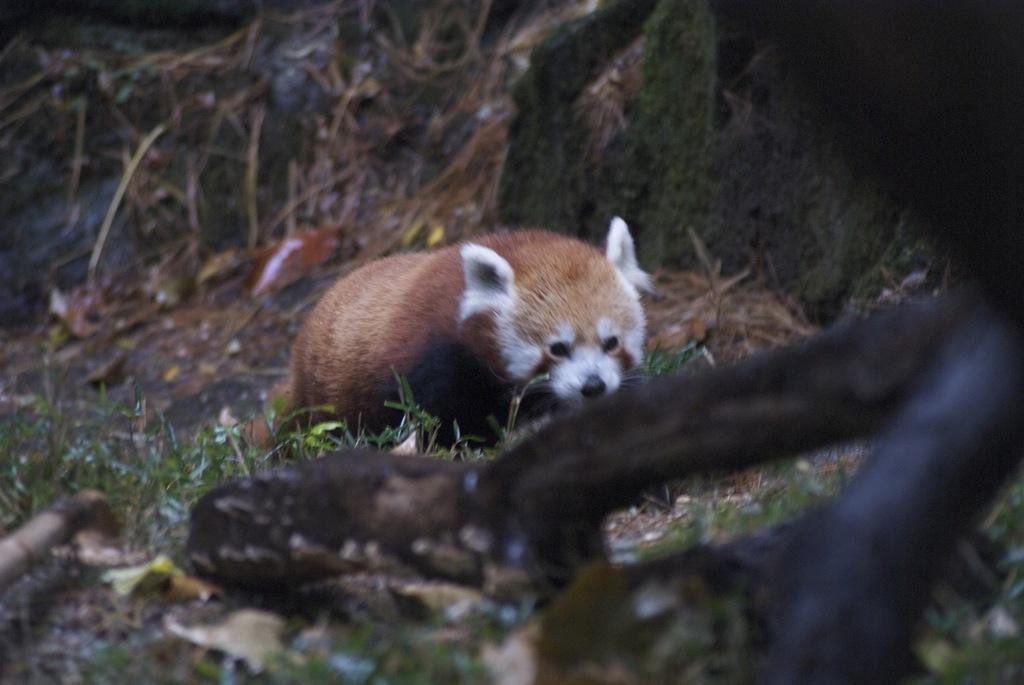Describe this image in one or two sentences. In this image I can see an animal which is in white and brown color. Background I can see grass in green color. 